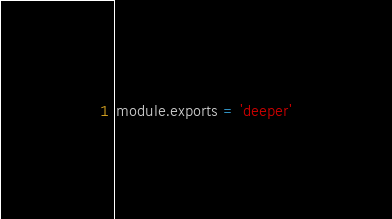<code> <loc_0><loc_0><loc_500><loc_500><_JavaScript_>module.exports = 'deeper'</code> 